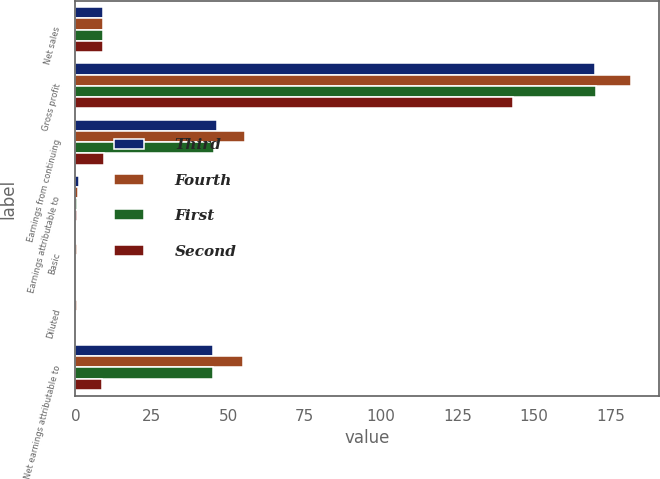Convert chart to OTSL. <chart><loc_0><loc_0><loc_500><loc_500><stacked_bar_chart><ecel><fcel>Net sales<fcel>Gross profit<fcel>Earnings from continuing<fcel>Earnings attributable to<fcel>Basic<fcel>Diluted<fcel>Net earnings attributable to<nl><fcel>Third<fcel>9<fcel>170<fcel>46.3<fcel>1.3<fcel>0.3<fcel>0.3<fcel>45<nl><fcel>Fourth<fcel>9<fcel>181.9<fcel>55.5<fcel>0.8<fcel>0.38<fcel>0.37<fcel>54.7<nl><fcel>First<fcel>9<fcel>170.4<fcel>45.3<fcel>0.4<fcel>0.31<fcel>0.31<fcel>44.9<nl><fcel>Second<fcel>9<fcel>143<fcel>9.3<fcel>0.6<fcel>0.06<fcel>0.06<fcel>8.7<nl></chart> 